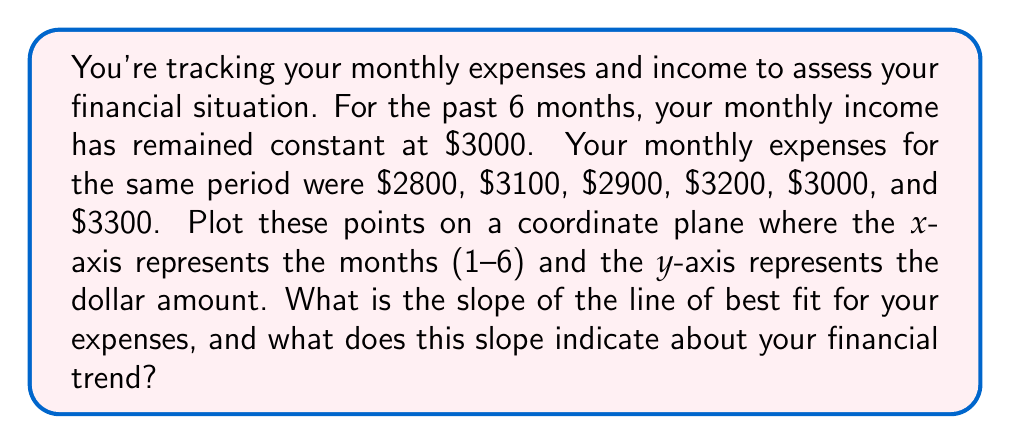Help me with this question. To solve this problem, we'll follow these steps:

1) First, let's plot the points on a coordinate plane. The x-coordinates will be the months (1-6), and the y-coordinates will be the expenses.

   (1, 2800), (2, 3100), (3, 2900), (4, 3200), (5, 3000), (6, 3300)

2) To find the line of best fit, we'll use the least squares method. The formula for the slope of the line of best fit is:

   $$m = \frac{n\sum xy - \sum x \sum y}{n\sum x^2 - (\sum x)^2}$$

   Where n is the number of points, x are the x-coordinates, and y are the y-coordinates.

3) Let's calculate the necessary sums:

   $\sum x = 1 + 2 + 3 + 4 + 5 + 6 = 21$
   $\sum y = 2800 + 3100 + 2900 + 3200 + 3000 + 3300 = 18300$
   $\sum xy = (1)(2800) + (2)(3100) + (3)(2900) + (4)(3200) + (5)(3000) + (6)(3300) = 64700$
   $\sum x^2 = 1^2 + 2^2 + 3^2 + 4^2 + 5^2 + 6^2 = 91$

4) Now, let's substitute these values into the slope formula:

   $$m = \frac{6(64700) - (21)(18300)}{6(91) - (21)^2}$$
   $$m = \frac{388200 - 384300}{546 - 441}$$
   $$m = \frac{3900}{105} = 37.14$$

5) The slope is approximately 37.14. This means that, on average, your monthly expenses are increasing by $37.14 each month.

This positive slope indicates an upward trend in your expenses, which could be concerning for your financial situation, especially since your income has remained constant at $3000 per month.
Answer: The slope of the line of best fit for the expenses is approximately 37.14, indicating that monthly expenses are increasing by an average of $37.14 each month. 